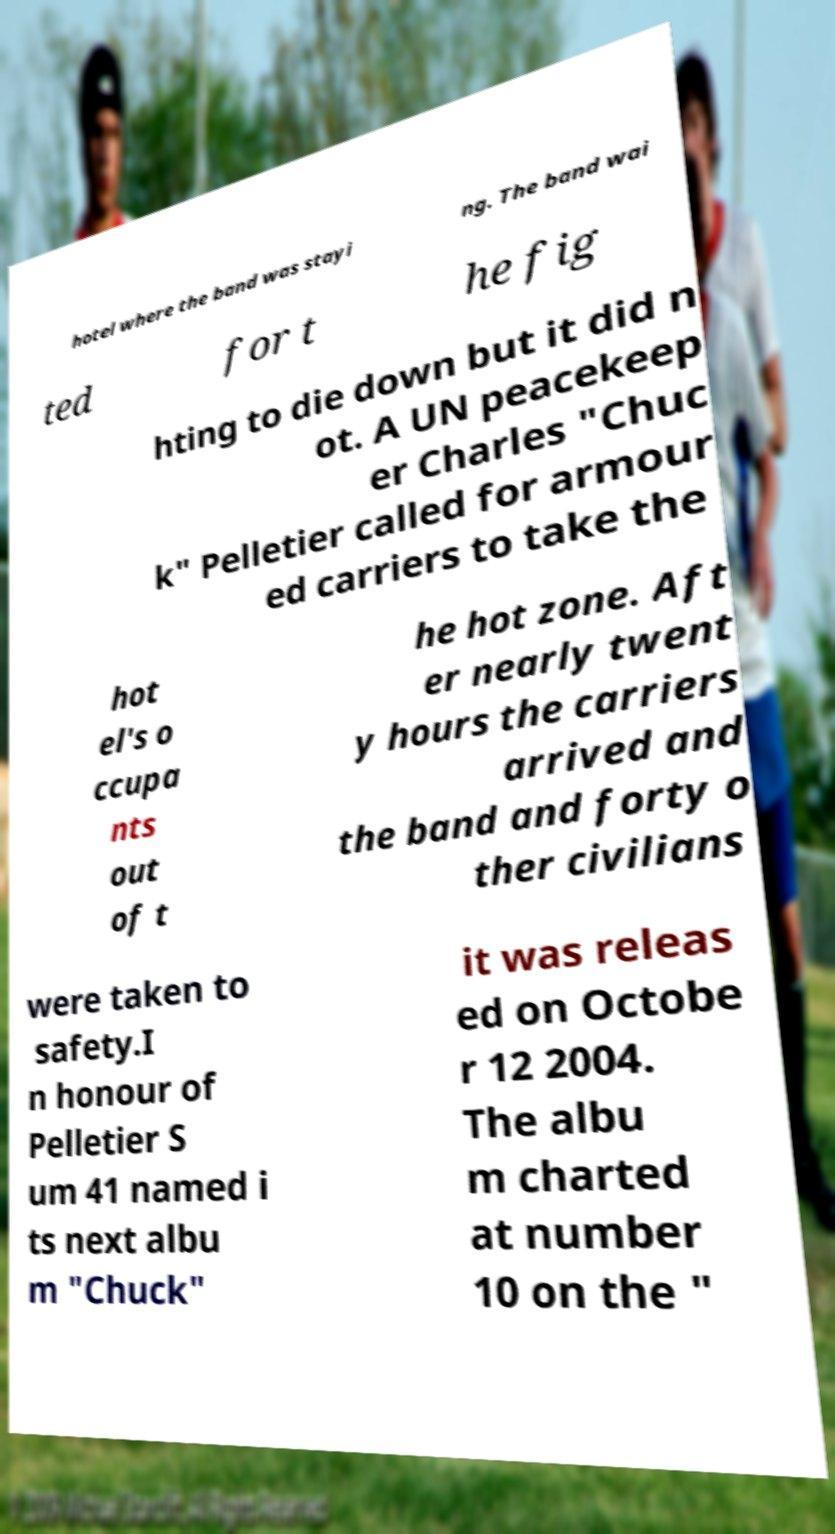I need the written content from this picture converted into text. Can you do that? hotel where the band was stayi ng. The band wai ted for t he fig hting to die down but it did n ot. A UN peacekeep er Charles "Chuc k" Pelletier called for armour ed carriers to take the hot el's o ccupa nts out of t he hot zone. Aft er nearly twent y hours the carriers arrived and the band and forty o ther civilians were taken to safety.I n honour of Pelletier S um 41 named i ts next albu m "Chuck" it was releas ed on Octobe r 12 2004. The albu m charted at number 10 on the " 